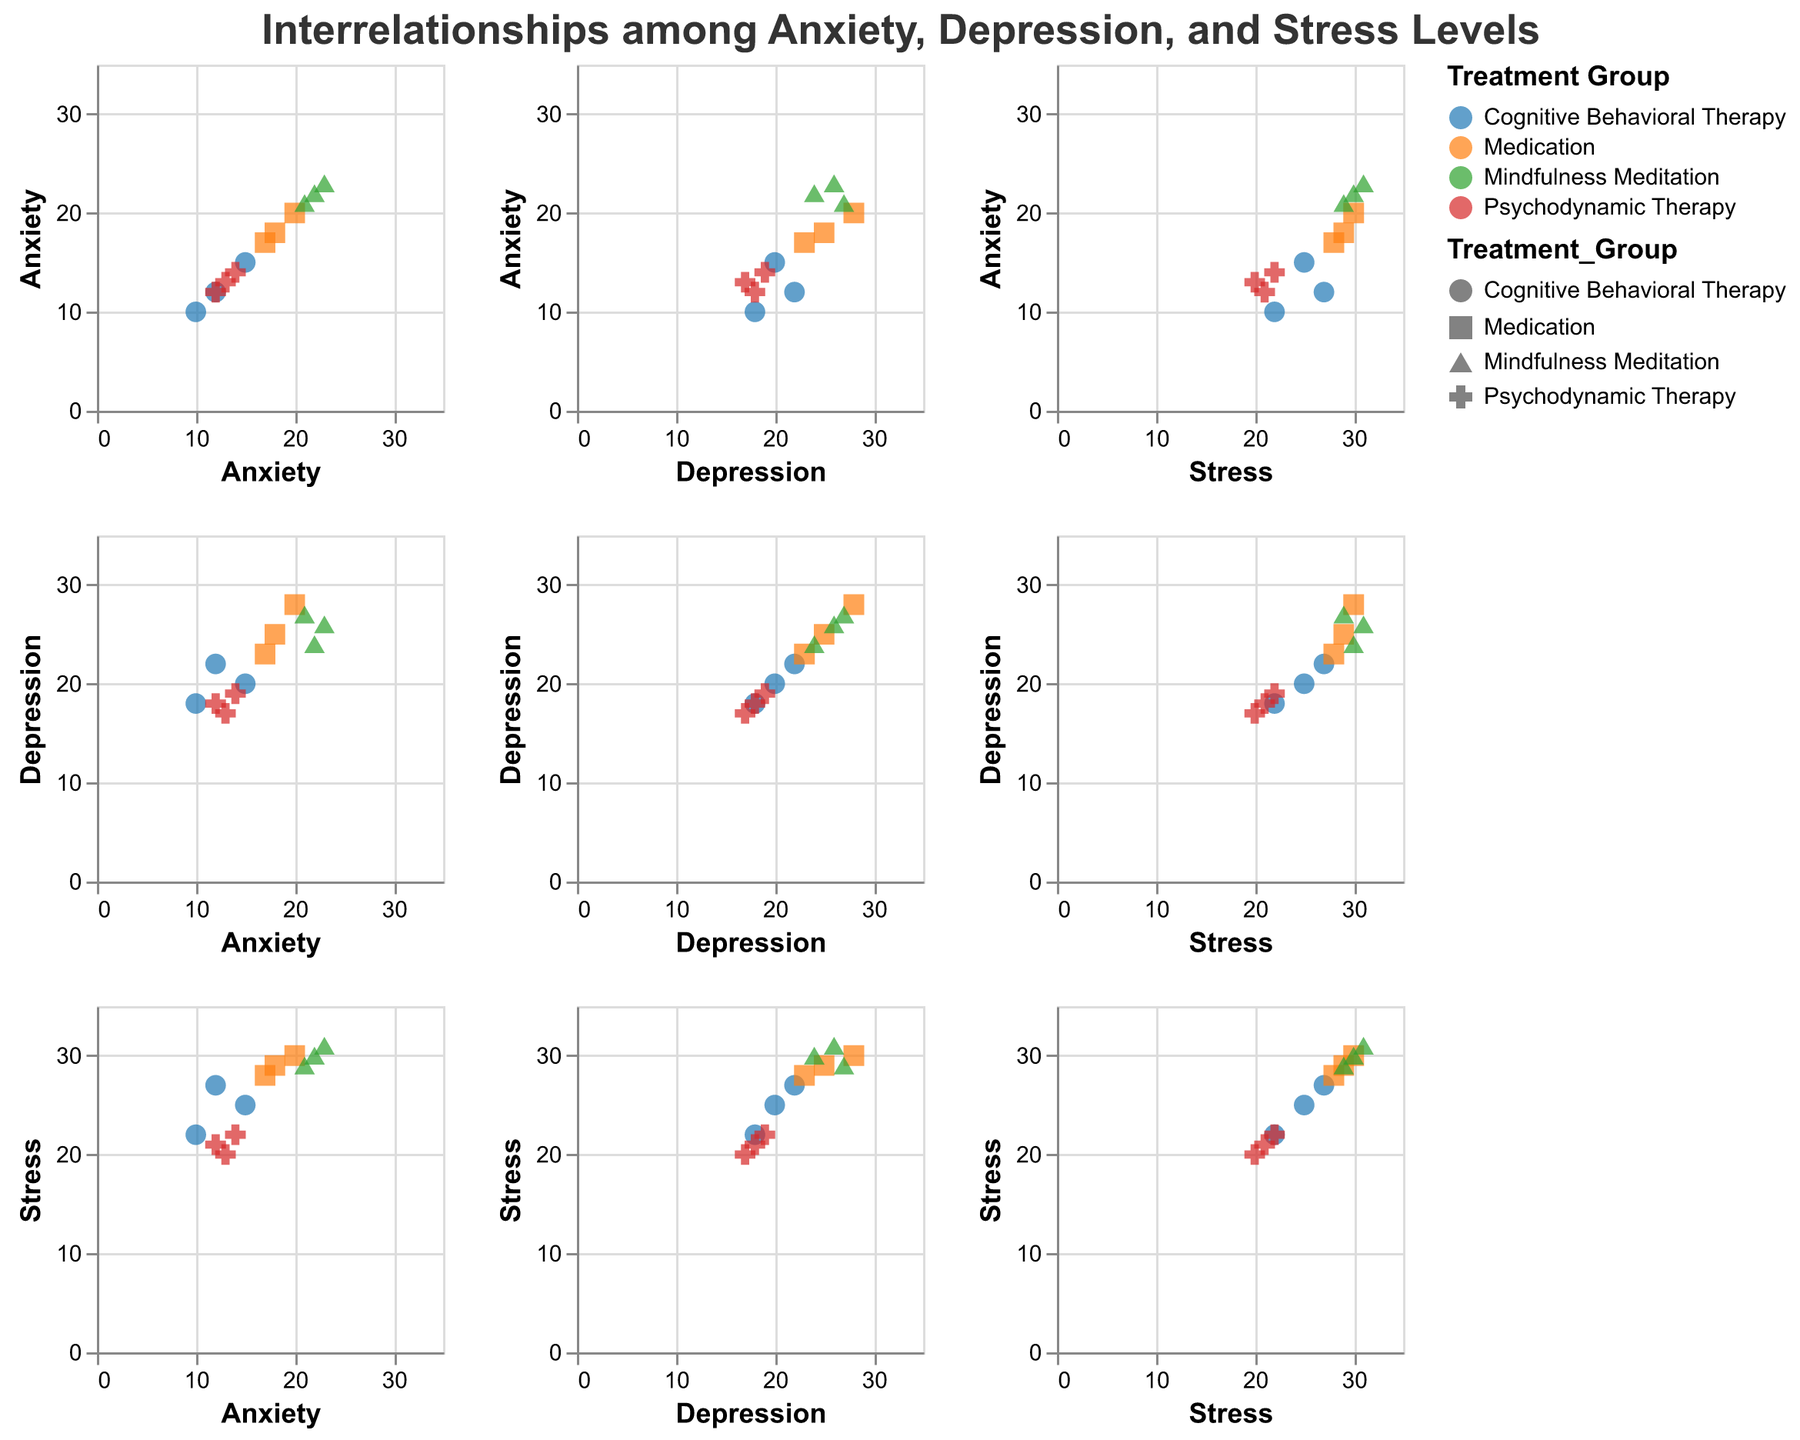What is the title of the figure? To find the title, look at the text displayed at the top of the figure.
Answer: Interrelationships among Anxiety, Depression, and Stress Levels How many treatment groups are represented in the figure? By referring to the legend, you can count the distinct groups or colors shown.
Answer: 4 Which treatment group covers the highest Anxiety value? Look for the scatter plot points with the highest Anxiety values and identify the corresponding treatment group color and shape from the legend. The highest Anxiety value here is for Mindfulness Meditation.
Answer: Mindfulness Meditation What is the range of the x-axis for Anxiety? The x-axis range can be observed from the plot, typically from the start to the end of the axis.
Answer: 0 to 35 Between which two treatment groups do Anxiety and Stress have the most similar trends? Look for the scatter plot points where Anxiety and Stress values are plotted and compare their similarities visually for different treatment groups. Cognitive Behavioral Therapy and Medication present quite similar trends.
Answer: Cognitive Behavioral Therapy and Medication What is the average Stress level in the Medication group? Find all data points for the Medication group and calculate their average Stress value: (30 + 29 + 28) / 3 = 29.
Answer: 29 Could you identify a trend between Anxiety and Depression within the Cognitive Behavioral Therapy group? Look at the scatter plot section comparing Anxiety and Depression for the specific color and shape corresponding to Cognitive Behavioral Therapy from the legend. There seems to be a positive trend between Anxiety and Depression in this group.
Answer: Positive trend Which plot showcases a direct positive relationship between Depression and Stress across all treatment groups? Analyze the Depression vs. Stress scatter plot and see if there's a uniform positive trend line seen across all colors and shapes representing the treatment groups.
Answer: Depression vs. Stress plot Which treatment group has overlapping data points in Anxiety vs Depression plot? Visually scan the plot for Anxiety vs Depression to see where colors and shapes corresponding to different treatment groups are overlapping. Cognitive Behavioral Therapy has some overlap with Psychodynamic Therapy.
Answer: Cognitive Behavioral Therapy and Psychodynamic Therapy Do the plots exhibit correlation between Anxiety and Stress for the Mindfulness Meditation group? Check the scatter plot showing Anxiety vs Stress and observe the color and shape specifically for Mindfulness Meditation points.
Answer: Yes 